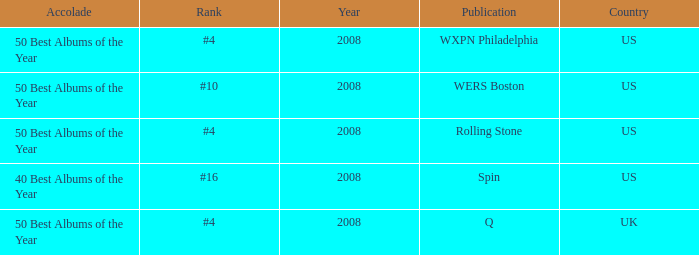Which rank's country is the US when the accolade is 40 best albums of the year? #16. 